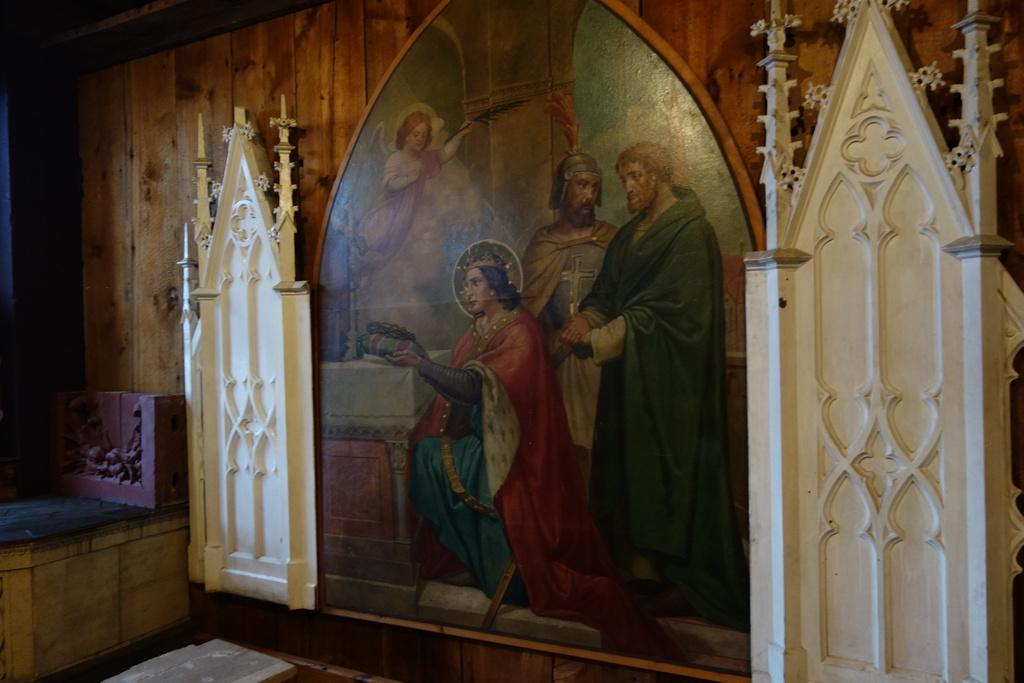What type of wall is featured in the image? There is a wooden wall in the image. What is displayed on the wooden wall? There is a painting on the wooden wall. What can be seen in the painting? The painting contains persons. Are there any additional elements on the wooden wall? Yes, there are decorations on the wooden wall. What type of apparatus is used to create the painting on the wooden wall? There is no information about the process or apparatus used to create the painting in the image. 